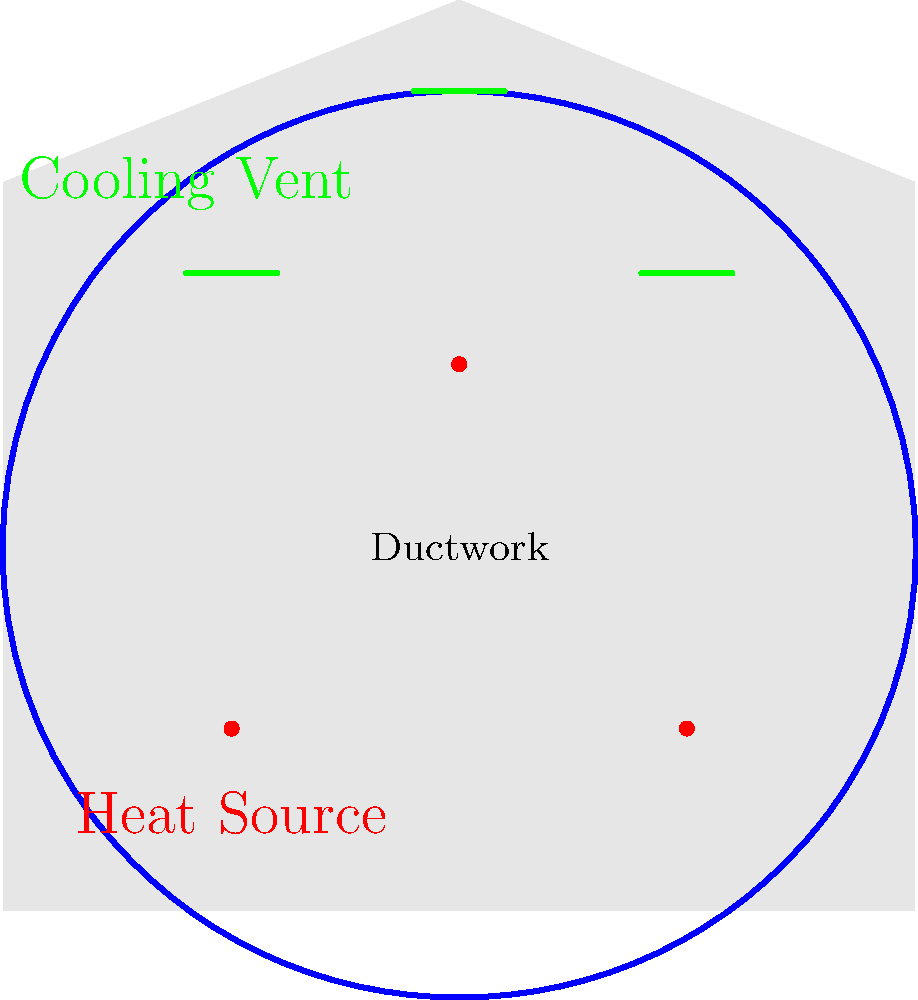In designing an efficient heating and cooling system for a large cathedral, which configuration would be most effective in maintaining a comfortable temperature throughout the space while minimizing energy consumption?

A) Centralized system with single large unit
B) Distributed system with multiple smaller units
C) Perimeter-based system with floor vents
D) Hybrid system combining radiant floor heating and forced air cooling To determine the most efficient heating and cooling system for a large cathedral, we need to consider several factors:

1. Volume: Cathedrals typically have high ceilings and large open spaces, making it challenging to maintain consistent temperatures.

2. Thermal stratification: Warm air rises, potentially creating temperature differences between floor and ceiling levels.

3. Historical preservation: Many cathedrals have architectural features that need to be preserved, limiting invasive installations.

4. Energy efficiency: The system should minimize energy consumption while providing adequate comfort.

5. Flexibility: The system should accommodate varying occupancy levels and seasonal changes.

Considering these factors:

A) A centralized system with a single large unit would struggle to distribute air evenly throughout the large space and may not effectively address thermal stratification.

B) A distributed system with multiple smaller units could provide more targeted heating and cooling, but may be more complex to install and maintain in a historic building.

C) A perimeter-based system with floor vents might not effectively reach all areas of the cathedral, especially the higher spaces.

D) A hybrid system combining radiant floor heating and forced air cooling offers several advantages:
   - Radiant floor heating provides efficient, even heat distribution from the ground up, addressing thermal stratification.
   - Forced air cooling can be used for both cooling and air circulation, helping to maintain consistent temperatures throughout the space.
   - This combination can be more energy-efficient, as radiant heat requires lower temperatures to achieve comfort compared to forced air heating.
   - The system can be designed to minimize visual impact on the cathedral's architecture.
   - It offers flexibility to adjust to varying occupancy levels and seasonal changes.

Therefore, the most effective configuration for maintaining a comfortable temperature while minimizing energy consumption would be option D: a hybrid system combining radiant floor heating and forced air cooling.
Answer: D) Hybrid system combining radiant floor heating and forced air cooling 